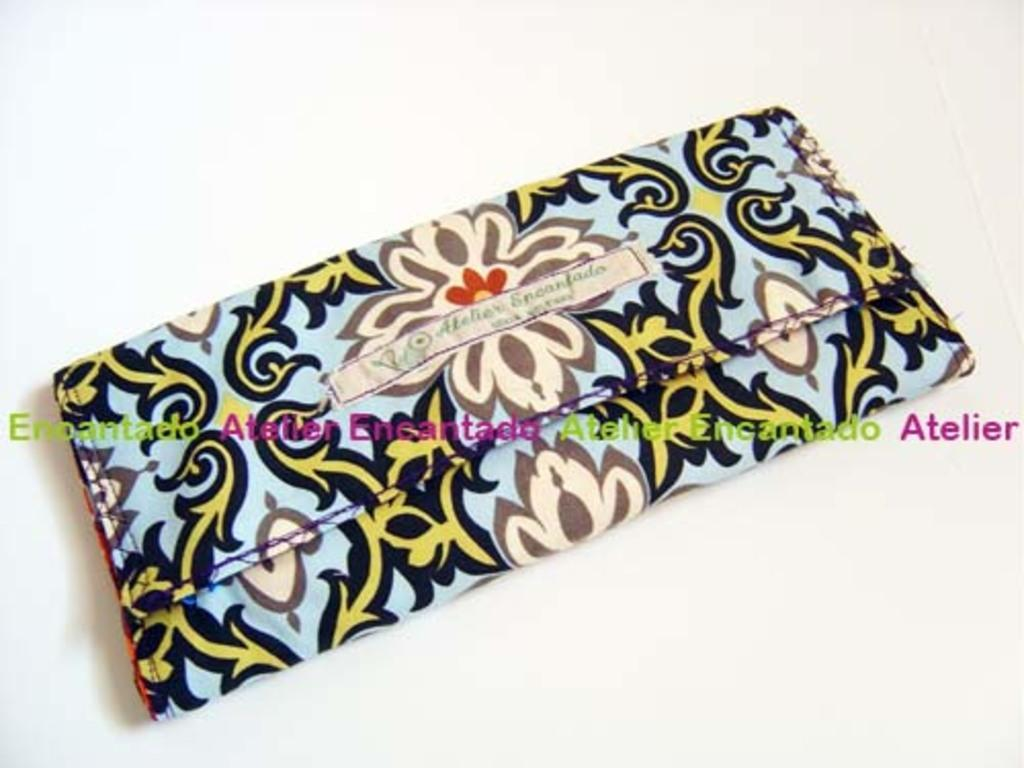What is placed on the white surface in the image? There is cloth on a white surface in the image. What can be seen on the cloth? There is text on the cloth. Can you describe the text visible in the image? There is text visible in the image. How does the coal affect the shock in the image? There is no coal or shock present in the image; it only features cloth with text on a white surface. 